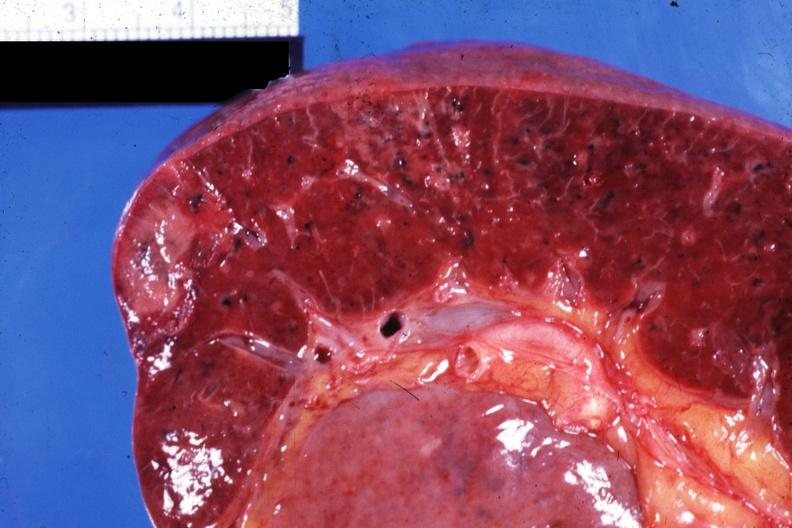does bone, calvarium show close-up view of infarcts due to nonbacterial endocarditis 88yom with body burns?
Answer the question using a single word or phrase. No 